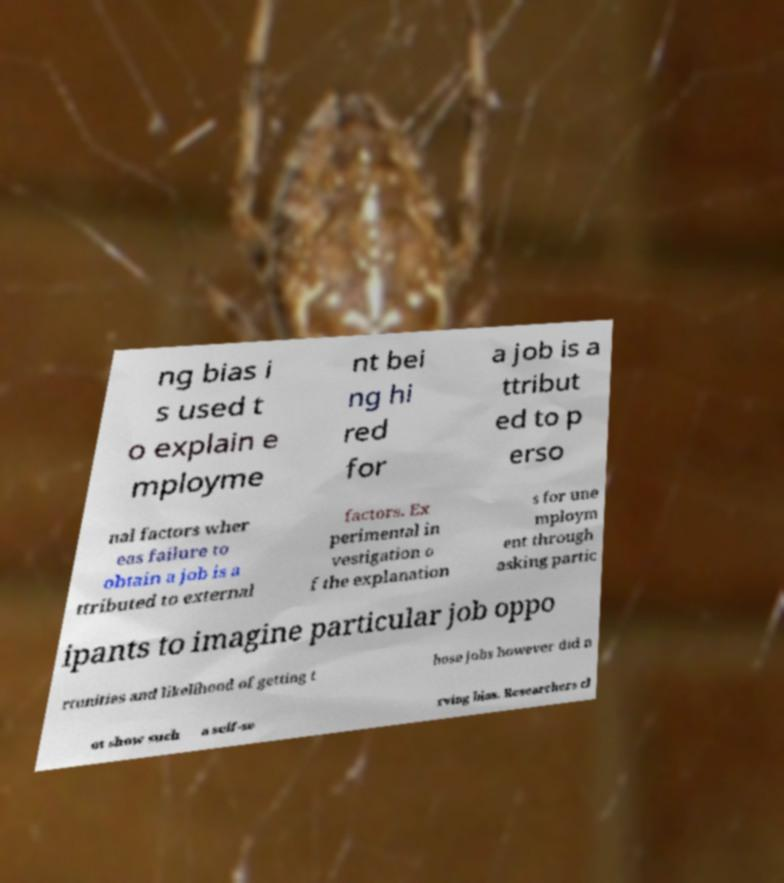There's text embedded in this image that I need extracted. Can you transcribe it verbatim? ng bias i s used t o explain e mployme nt bei ng hi red for a job is a ttribut ed to p erso nal factors wher eas failure to obtain a job is a ttributed to external factors. Ex perimental in vestigation o f the explanation s for une mploym ent through asking partic ipants to imagine particular job oppo rtunities and likelihood of getting t hose jobs however did n ot show such a self-se rving bias. Researchers cl 